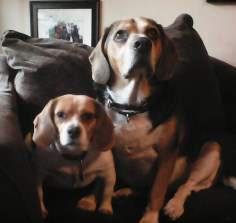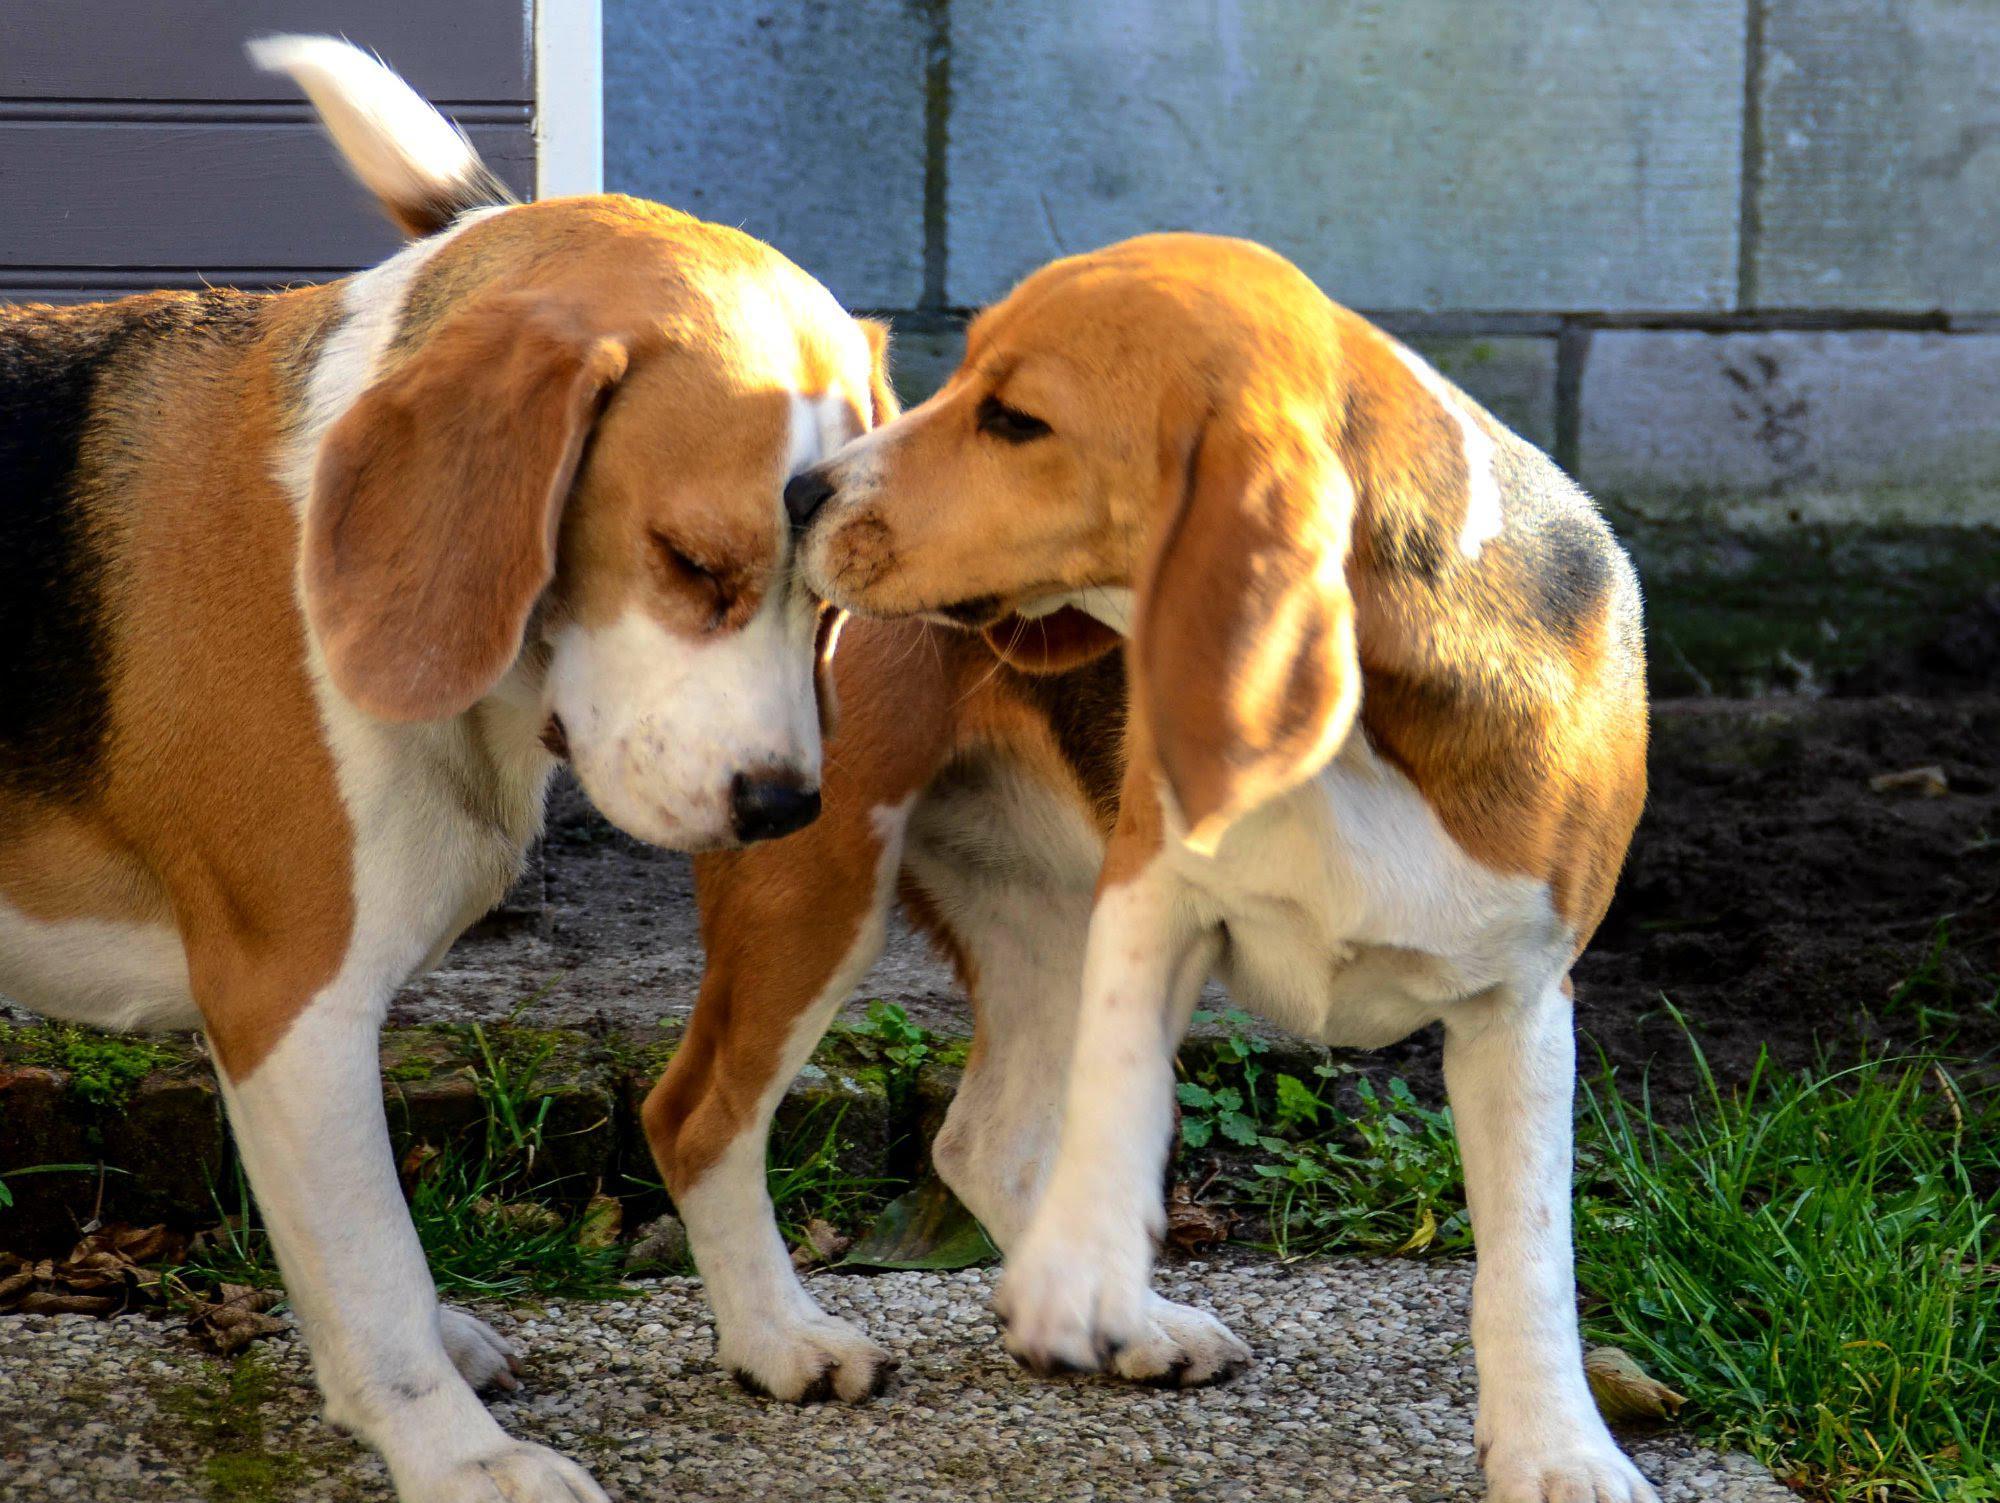The first image is the image on the left, the second image is the image on the right. Considering the images on both sides, is "There are two beagles in each image." valid? Answer yes or no. Yes. 